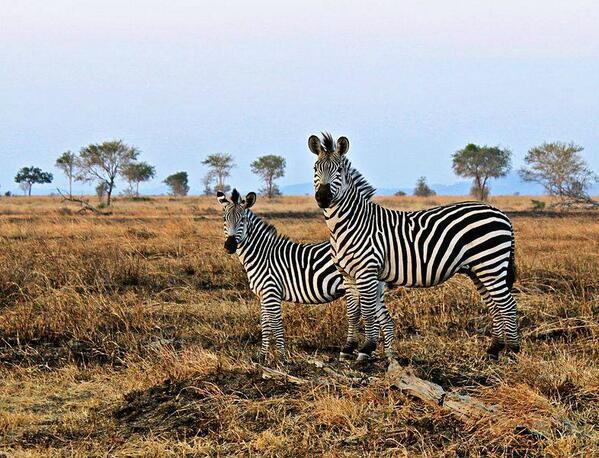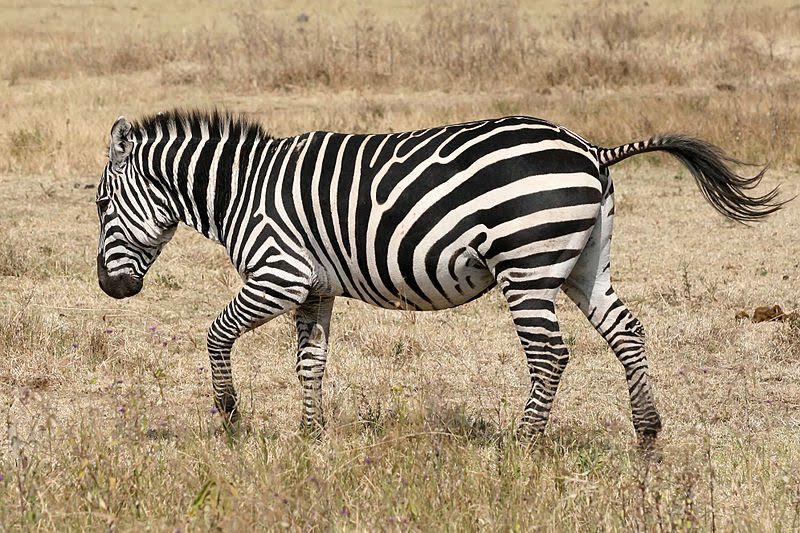The first image is the image on the left, the second image is the image on the right. For the images shown, is this caption "There are three zebras" true? Answer yes or no. Yes. 